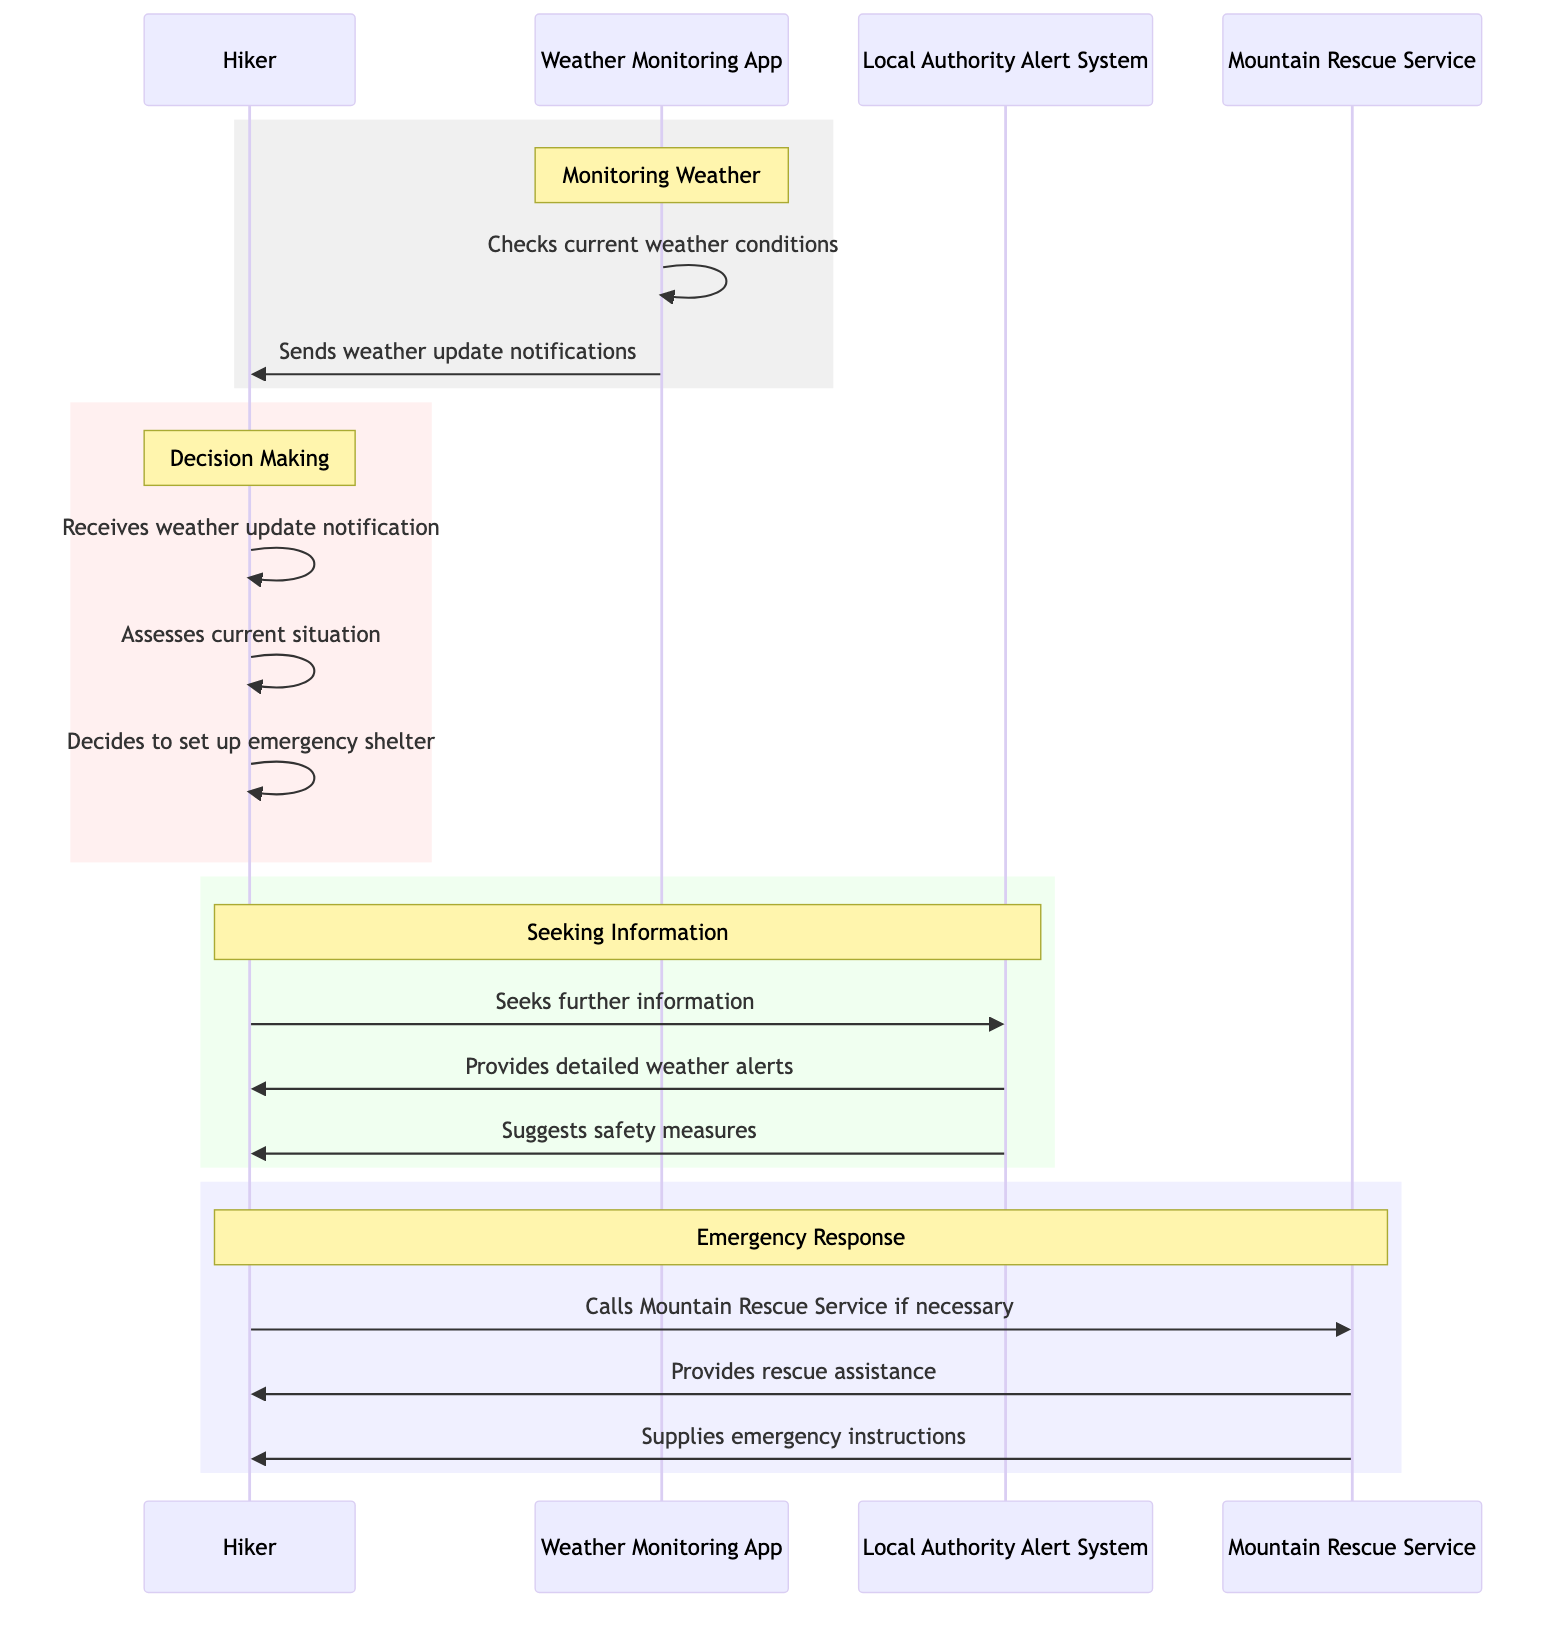What is the first action taken by the Weather Monitoring App? The first action taken by the Weather Monitoring App is to check the current weather conditions, as shown in the sequence at the beginning of the monitoring phase.
Answer: Checks current weather conditions How many actors are involved in the diagram? There are four actors involved: Hiker, Weather Monitoring App, Local Authority Alert System, and Mountain Rescue Service.
Answer: Four What does the Local Authority Alert System provide to the Hiker? The Local Authority Alert System provides detailed weather alerts and suggests safety measures to the Hiker when sought.
Answer: Detailed weather alerts and safety measures What decision does the Hiker make after receiving the weather update notification? After receiving the weather update notification, the Hiker decides to set up an emergency shelter as part of their immediate response to changing conditions.
Answer: Decides to set up emergency shelter What happens after the Hiker seeks further information from the Local Authority Alert System? After seeking further information, the Hiker receives detailed weather alerts and suggestions for safety measures from the Local Authority Alert System, which are essential to guide their next steps.
Answer: Provides detailed weather alerts and suggests safety measures If the Hiker feels it's necessary, who do they call for help? If necessary, the Hiker calls the Mountain Rescue Service for assistance in case the situation requires professional help, according to the emergency response protocol.
Answer: Mountain Rescue Service What action does the Mountain Rescue Service take if called? When called, the Mountain Rescue Service provides rescue assistance and supplies emergency instructions to the Hiker, supporting them in the emergency situation.
Answer: Provides rescue assistance and supplies emergency instructions 